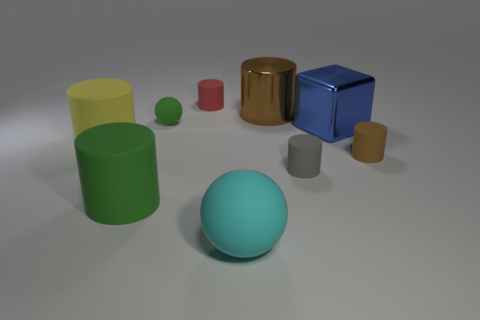Subtract all rubber cylinders. How many cylinders are left? 1 Add 1 small red cylinders. How many objects exist? 10 Subtract all green balls. How many brown cylinders are left? 2 Subtract all green cylinders. How many cylinders are left? 5 Subtract 1 cylinders. How many cylinders are left? 5 Add 6 brown objects. How many brown objects exist? 8 Subtract 1 blue blocks. How many objects are left? 8 Subtract all balls. How many objects are left? 7 Subtract all blue spheres. Subtract all red cylinders. How many spheres are left? 2 Subtract all yellow cylinders. Subtract all brown shiny cylinders. How many objects are left? 7 